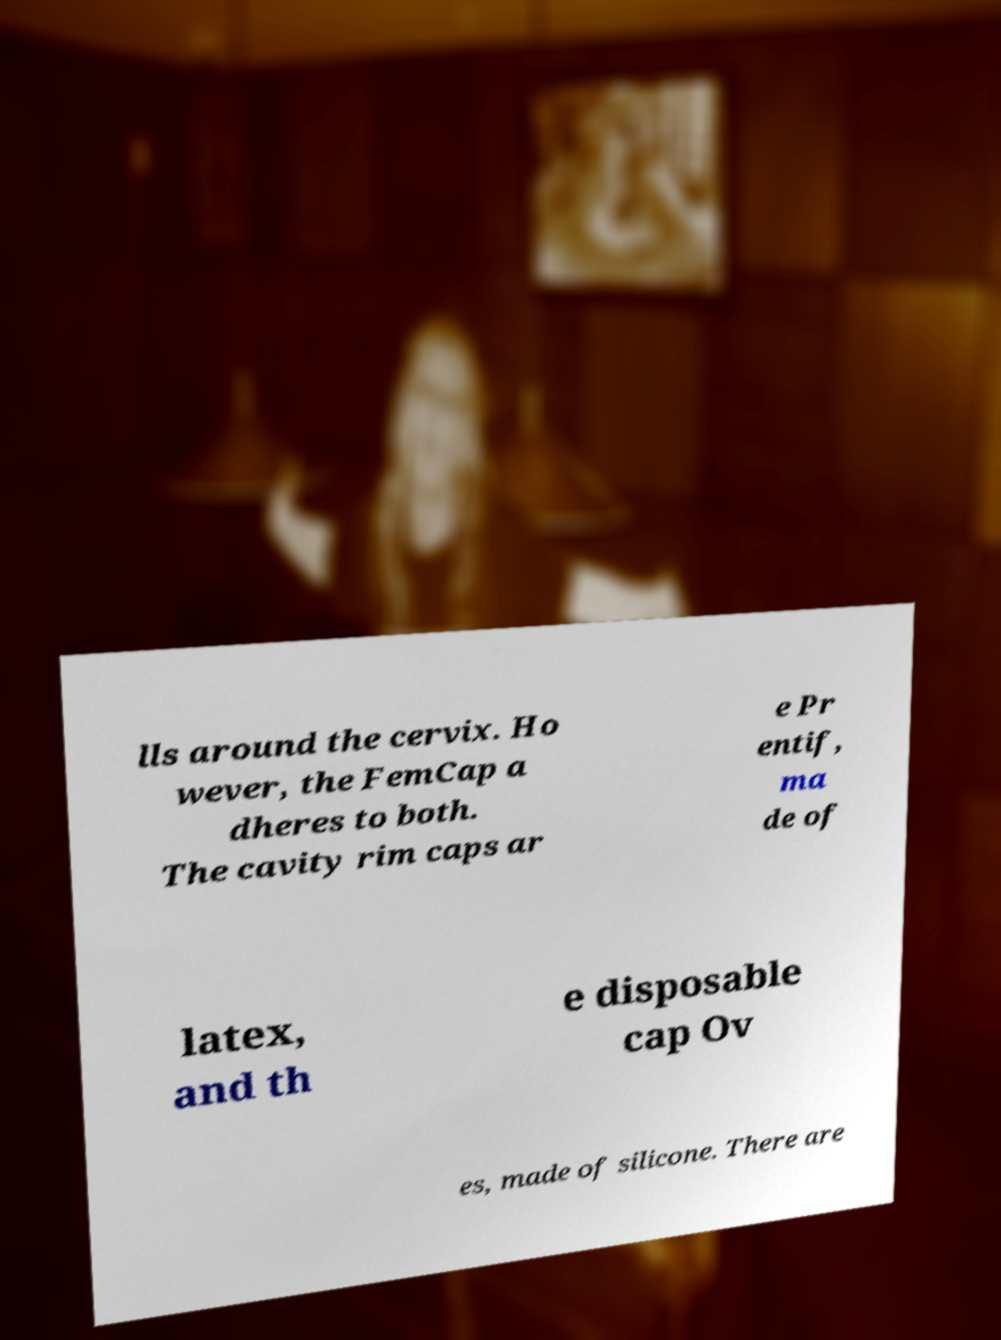For documentation purposes, I need the text within this image transcribed. Could you provide that? lls around the cervix. Ho wever, the FemCap a dheres to both. The cavity rim caps ar e Pr entif, ma de of latex, and th e disposable cap Ov es, made of silicone. There are 